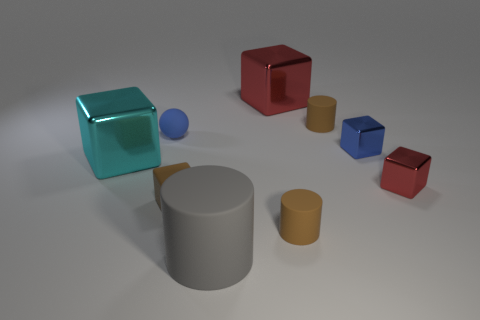What is the size of the gray rubber object?
Make the answer very short. Large. The other large block that is the same material as the large red block is what color?
Offer a terse response. Cyan. What number of brown matte objects are the same size as the blue rubber ball?
Offer a terse response. 3. Is the material of the brown object to the left of the big red thing the same as the large red object?
Give a very brief answer. No. Is the number of big gray things behind the large red cube less than the number of gray rubber objects?
Your response must be concise. Yes. There is a tiny brown rubber object to the left of the large matte cylinder; what is its shape?
Provide a succinct answer. Cube. There is a metallic thing that is the same size as the cyan block; what is its shape?
Make the answer very short. Cube. Are there any big cyan shiny things of the same shape as the gray object?
Offer a terse response. No. Is the shape of the red thing that is behind the cyan shiny block the same as the metal object that is on the left side of the gray cylinder?
Provide a short and direct response. Yes. There is a cyan object that is the same size as the gray object; what is it made of?
Provide a succinct answer. Metal. 